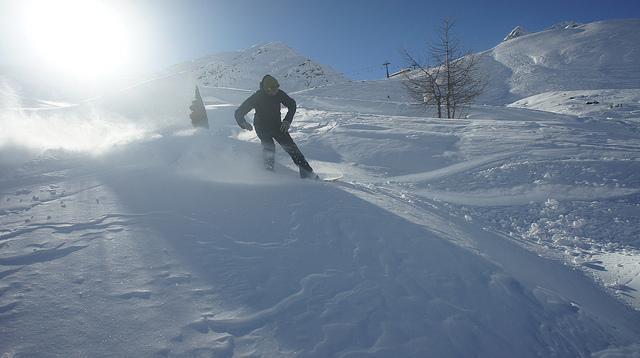How many chairs in this image are not placed at the table by the window?
Give a very brief answer. 0. 